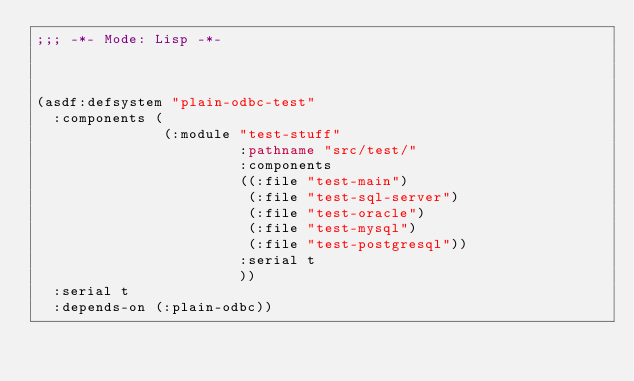Convert code to text. <code><loc_0><loc_0><loc_500><loc_500><_Lisp_>;;; -*- Mode: Lisp -*-



(asdf:defsystem "plain-odbc-test"
  :components (
               (:module "test-stuff"
                        :pathname "src/test/"
                        :components 
                        ((:file "test-main")
                         (:file "test-sql-server")
                         (:file "test-oracle")
                         (:file "test-mysql")
                         (:file "test-postgresql"))
                        :serial t
                        ))
  :serial t
  :depends-on (:plain-odbc))</code> 